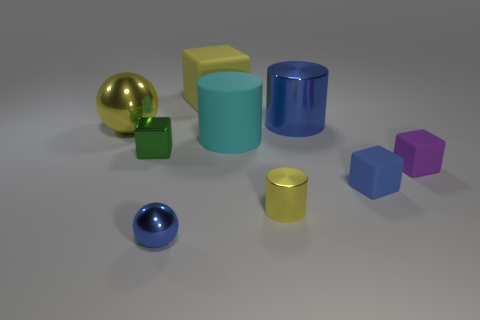Is there a shiny cylinder of the same size as the blue rubber thing?
Provide a succinct answer. Yes. What material is the other yellow object that is the same size as the yellow rubber thing?
Your answer should be very brief. Metal. There is a thing that is behind the yellow sphere and on the left side of the blue metallic cylinder; what shape is it?
Your response must be concise. Cube. There is a large thing left of the green shiny cube; what is its color?
Ensure brevity in your answer.  Yellow. There is a blue object that is both to the right of the tiny shiny cylinder and in front of the small green block; how big is it?
Your answer should be compact. Small. Does the large blue thing have the same material as the large cyan cylinder that is in front of the yellow matte thing?
Keep it short and to the point. No. How many other things are the same shape as the large yellow metallic thing?
Your response must be concise. 1. There is a small cylinder that is the same color as the large rubber block; what is it made of?
Give a very brief answer. Metal. What number of rubber cubes are there?
Your answer should be very brief. 3. Do the tiny blue rubber thing and the yellow metallic object behind the matte cylinder have the same shape?
Ensure brevity in your answer.  No. 